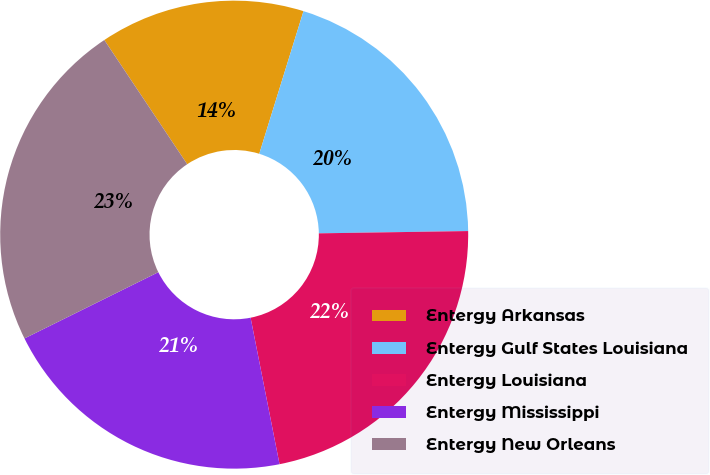Convert chart to OTSL. <chart><loc_0><loc_0><loc_500><loc_500><pie_chart><fcel>Entergy Arkansas<fcel>Entergy Gulf States Louisiana<fcel>Entergy Louisiana<fcel>Entergy Mississippi<fcel>Entergy New Orleans<nl><fcel>14.15%<fcel>19.97%<fcel>22.14%<fcel>20.79%<fcel>22.95%<nl></chart> 